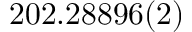Convert formula to latex. <formula><loc_0><loc_0><loc_500><loc_500>2 0 2 . 2 8 8 9 6 ( 2 )</formula> 